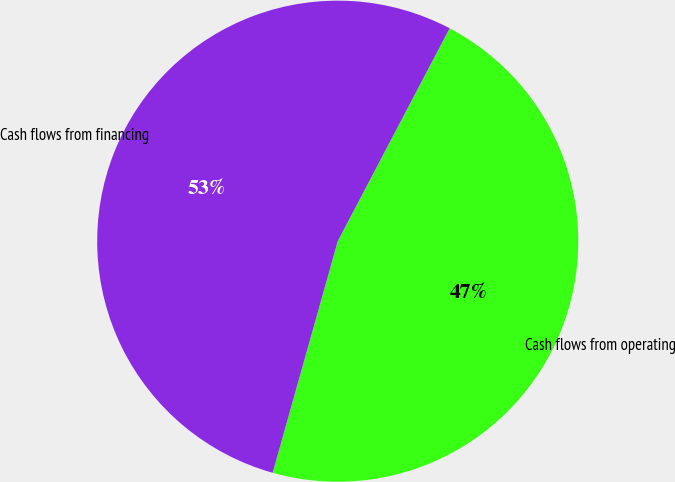Convert chart. <chart><loc_0><loc_0><loc_500><loc_500><pie_chart><fcel>Cash flows from operating<fcel>Cash flows from financing<nl><fcel>46.66%<fcel>53.34%<nl></chart> 